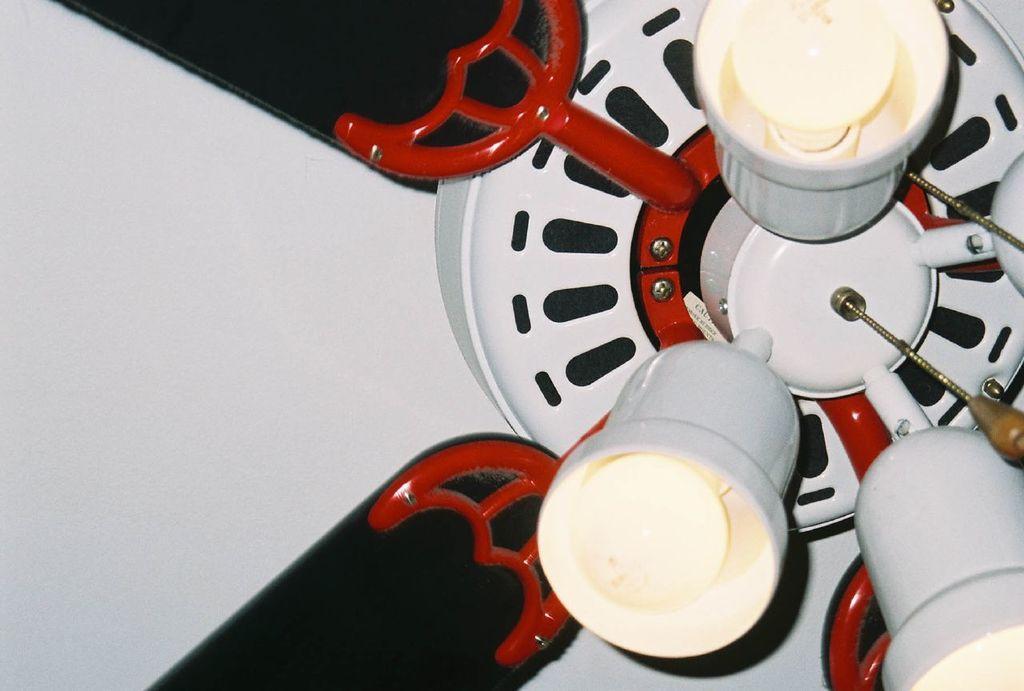How would you summarize this image in a sentence or two? In this picture we can see a decorative ceiling fan with lights. 